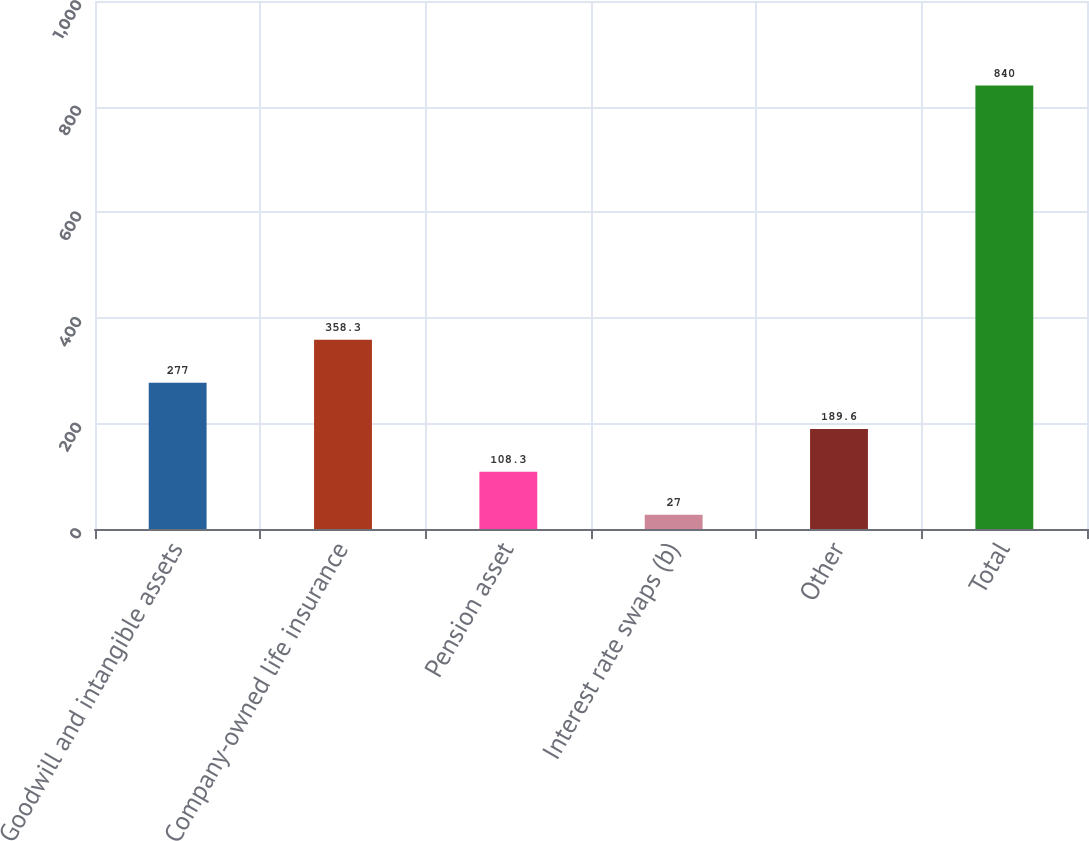Convert chart to OTSL. <chart><loc_0><loc_0><loc_500><loc_500><bar_chart><fcel>Goodwill and intangible assets<fcel>Company-owned life insurance<fcel>Pension asset<fcel>Interest rate swaps (b)<fcel>Other<fcel>Total<nl><fcel>277<fcel>358.3<fcel>108.3<fcel>27<fcel>189.6<fcel>840<nl></chart> 